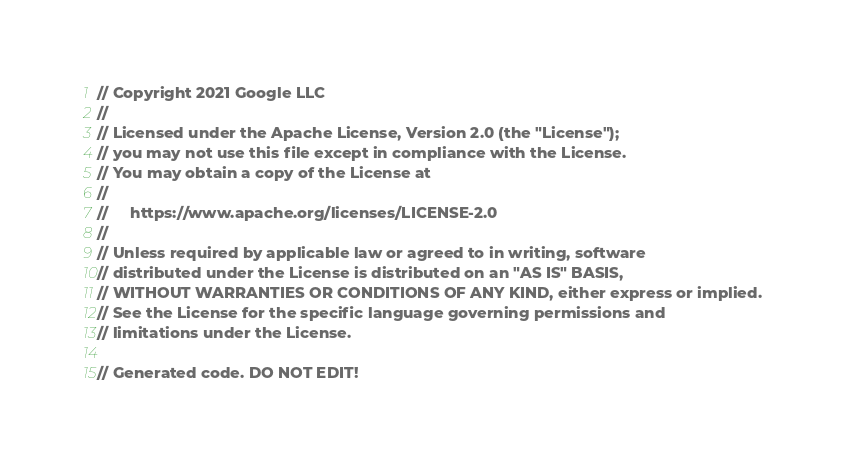<code> <loc_0><loc_0><loc_500><loc_500><_C#_>// Copyright 2021 Google LLC
//
// Licensed under the Apache License, Version 2.0 (the "License");
// you may not use this file except in compliance with the License.
// You may obtain a copy of the License at
//
//     https://www.apache.org/licenses/LICENSE-2.0
//
// Unless required by applicable law or agreed to in writing, software
// distributed under the License is distributed on an "AS IS" BASIS,
// WITHOUT WARRANTIES OR CONDITIONS OF ANY KIND, either express or implied.
// See the License for the specific language governing permissions and
// limitations under the License.

// Generated code. DO NOT EDIT!
</code> 